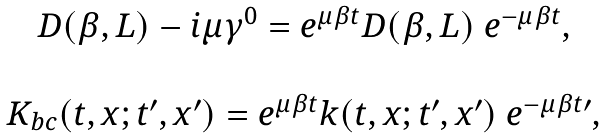Convert formula to latex. <formula><loc_0><loc_0><loc_500><loc_500>\begin{array} { c } D ( \beta , L ) - i \mu \gamma ^ { 0 } = e ^ { \mu \beta t } D ( \beta , L ) \ e ^ { - \mu \beta t } , \\ \\ K _ { b c } ( t , x ; t ^ { \prime } , x ^ { \prime } ) = e ^ { \mu \beta t } k ( t , x ; t ^ { \prime } , x ^ { \prime } ) \ e ^ { - \mu \beta t \prime } , \end{array}</formula> 